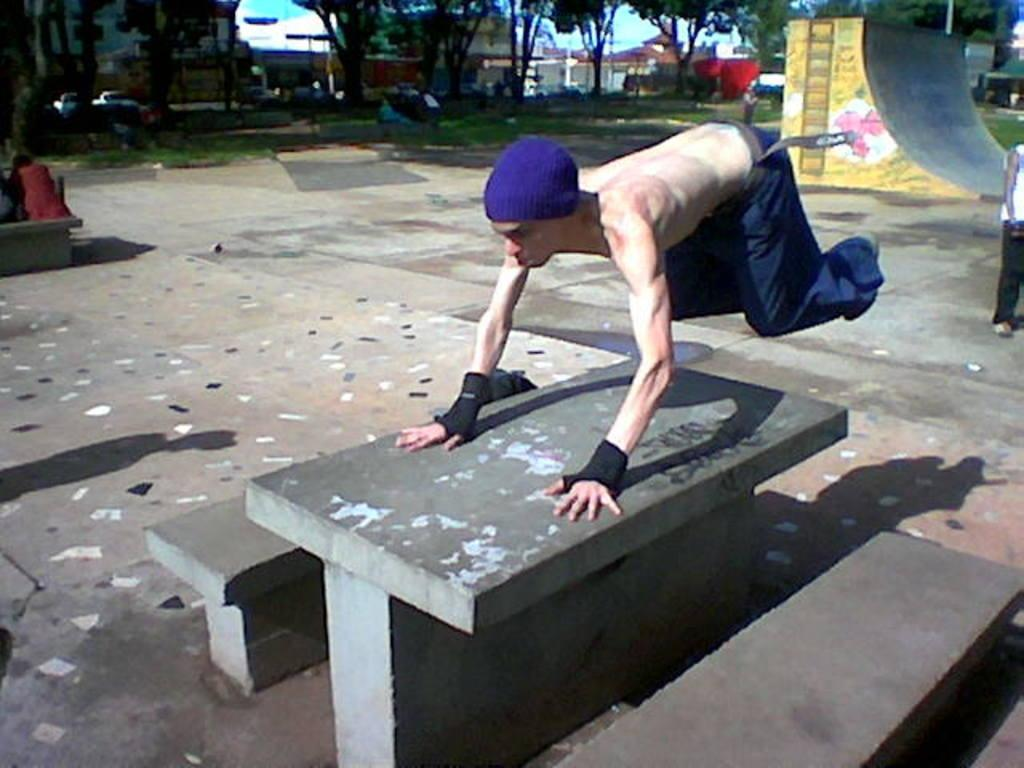Who is present in the image? There is a man in the picture. What is the man wearing on his head? The man is wearing a blue head wear. What can be seen in the background of the image? There are plants, trees, and buildings in the background of the picture. What is the condition of the sky in the image? The sky is clear in the image. Can you tell me how many boats are visible in the image? There are no boats present in the image. What type of bread is the man holding in the image? There is no bread present in the image. 